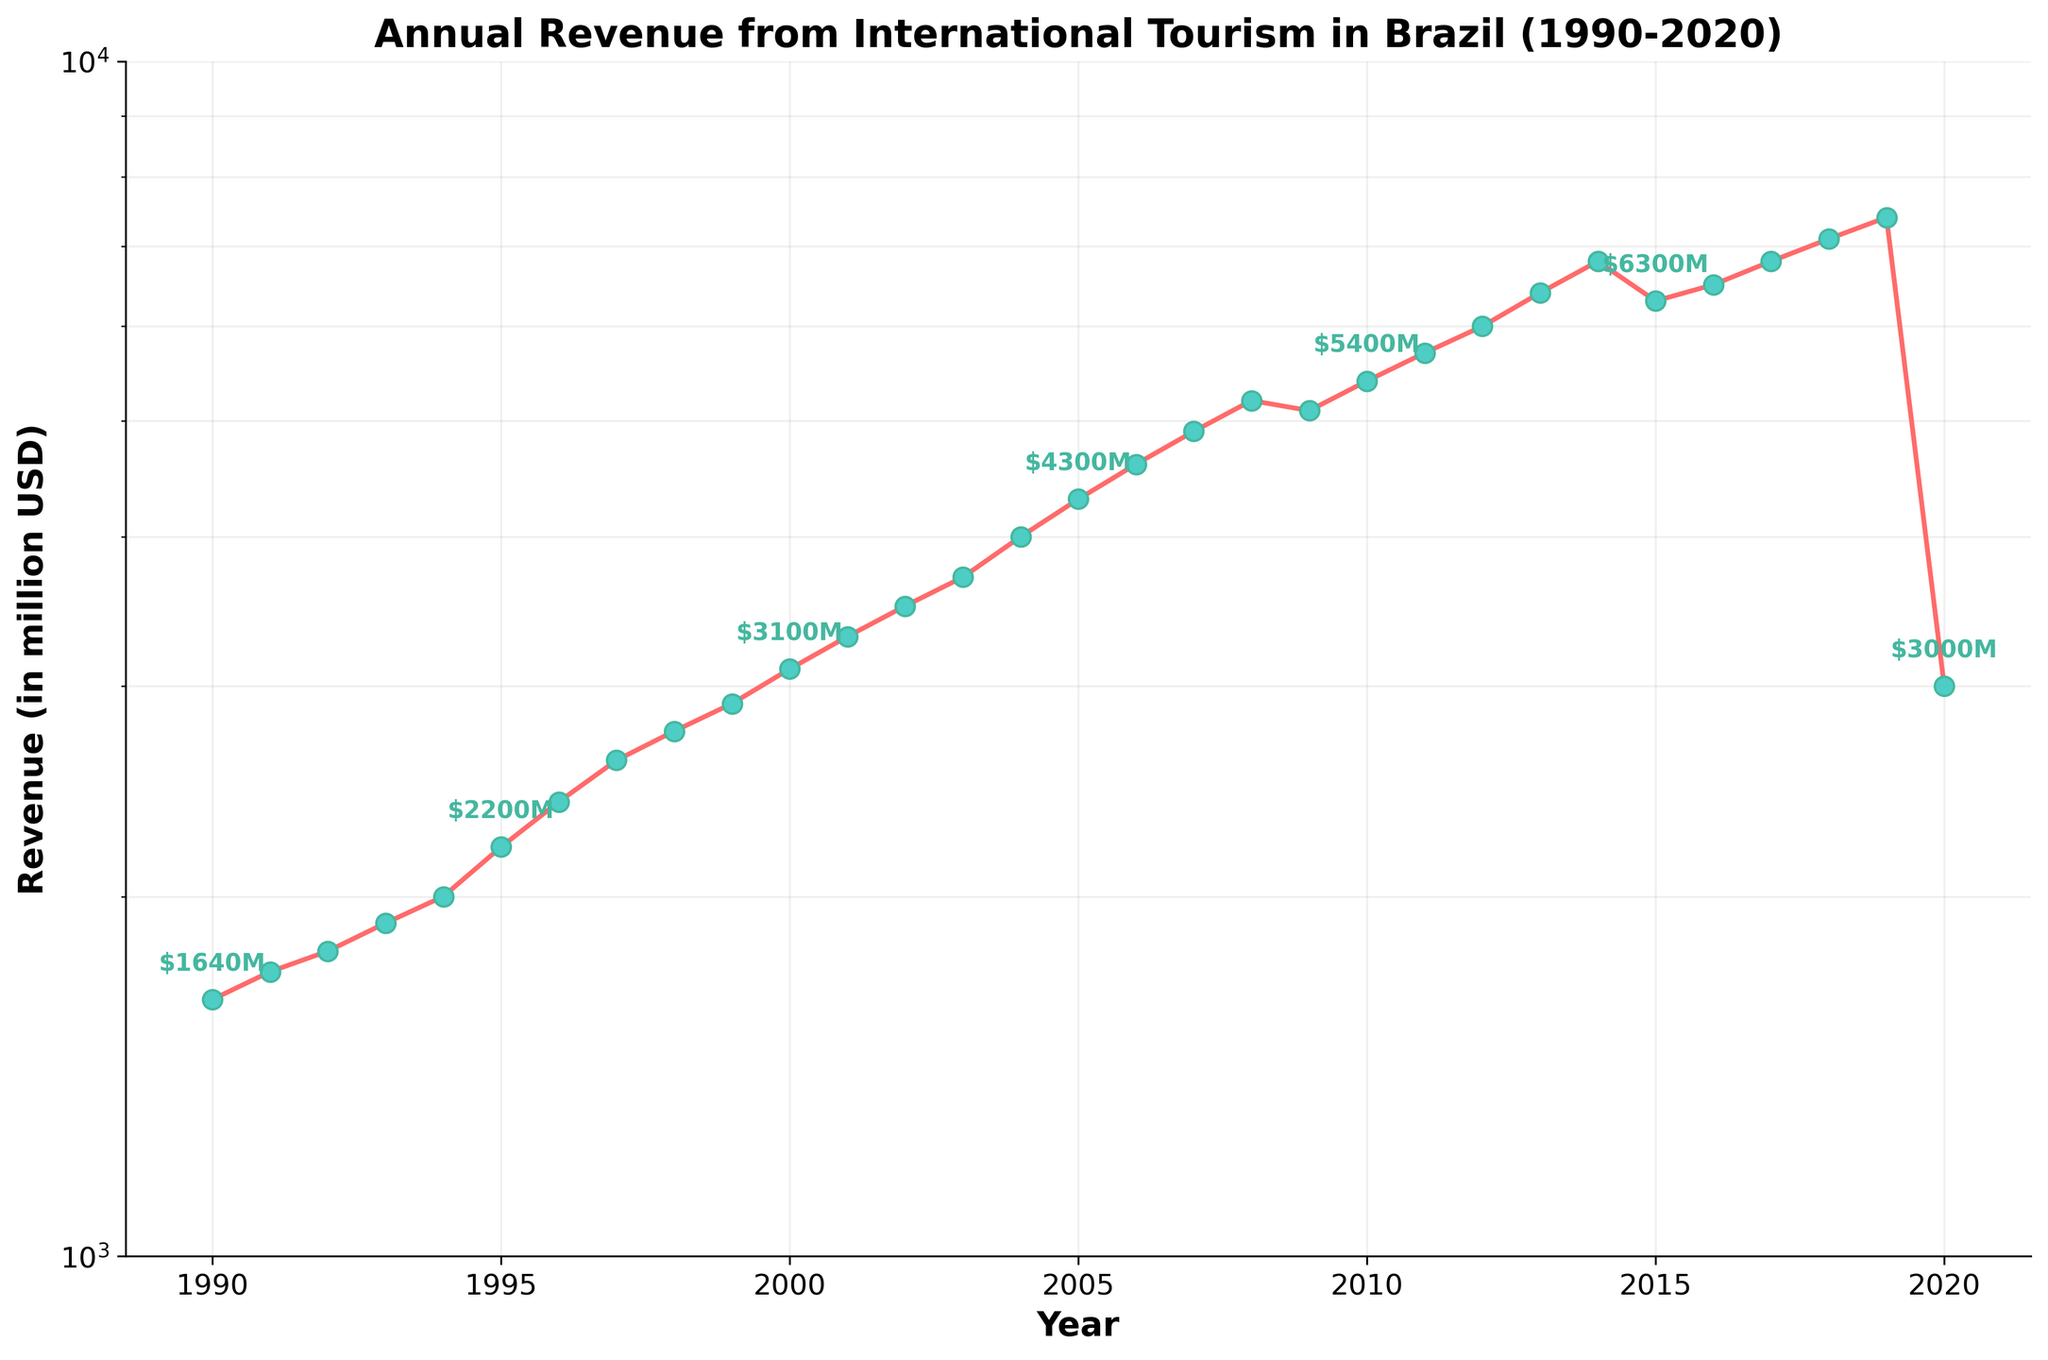When did the annual revenue from international tourism in Brazil first exceed $5000 million? Look at the plot and identify the first year where the revenue crosses the $5000 million mark. This happens in 2008.
Answer: 2008 What was the effect of the year 2020 on Brazil's tourism revenue compared to 2019? Locate the points for 2019 and 2020. The revenue dropped significantly from $7400 million in 2019 to $3000 million in 2020.
Answer: Significant decrease What is the general trend of Brazil's international tourism revenue from 1990 to 2020? Examine the overall direction of the line plot. The revenue generally increased over time with some fluctuations, particularly a sharp decrease in 2020.
Answer: Increasing trend with fluctuations How does the revenue in 2001 compare to that in 2015? Check the plot points for 2001 and 2015. In 2001, the revenue was $3300 million, whereas in 2015 it was $6300 million.
Answer: 2015 is higher What are the years when the revenue either plateaued or decreased? Identify the years where the line plot either remains flat or goes down. This occurs around 2008-2009, 2014-2015, and 2019-2020.
Answer: 2008-2009, 2014-2015, and 2019-2020 What is the average annual revenue from international tourism in Brazil for the decades 1990-1999 and 2000-2009? Calculate the average for each decade. For 1990-1999, the sum is $21420 million for 10 years, so the average is $2142 million. For 2000-2009, the sum is $36200 million for 10 years, so the average is $3620 million.
Answer: 1990-1999: $2142 million, 2000-2009: $3620 million How does the revenue growth rate from 1990 to 2000 compare to that from 2010 to 2020? Calculate the growth rate for both periods. From 1990 ($1640 million) to 2000 ($3100 million), the growth rate is ($3100 - $1640) / $1640 * 100%. From 2010 ($5400 million) to 2020 ($3000 million), the rate is ($3000 - $5400) / $5400 * 100%.
Answer: 1990-2000: 89%, 2010-2020: -44% What is the maximum revenue recorded and in which year did it occur? Identify the highest point on the line plot. The maximum revenue is $7400 million in 2019.
Answer: $7400 million in 2019 How much did the revenue increase from 2002 to 2004? Subtract the revenue in 2002 from that in 2004. The revenue increased from $3500 million in 2002 to $4000 million in 2004.
Answer: Increased by $500 million What patterns can be observed in the revenue changes between 2015 and 2020? Observe the fluctuations during the years 2015 to 2020. There is a slight increase in 2016 and 2017, followed by a steady increase to 2019, and a sharp decline in 2020.
Answer: Fluctuating with a significant drop in 2020 